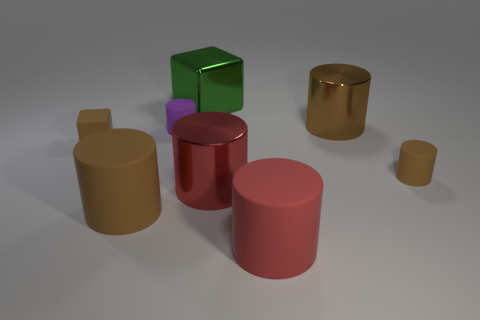Is there another tiny matte object of the same shape as the tiny purple object?
Offer a terse response. Yes. There is a large brown object that is on the right side of the red cylinder that is behind the red matte cylinder; what is it made of?
Provide a short and direct response. Metal. What is the size of the purple rubber cylinder?
Provide a short and direct response. Small. What size is the other brown cylinder that is the same material as the small brown cylinder?
Provide a short and direct response. Large. There is a cylinder left of the purple cylinder; is its size the same as the brown matte cube?
Your answer should be compact. No. What is the shape of the thing that is in front of the brown rubber thing that is in front of the metallic thing that is in front of the small block?
Your answer should be compact. Cylinder. How many objects are either large red shiny objects or matte cylinders left of the red metallic cylinder?
Your response must be concise. 3. There is a cube to the right of the big brown matte cylinder; what is its size?
Your answer should be compact. Large. There is a shiny object that is the same color as the tiny rubber cube; what shape is it?
Your answer should be very brief. Cylinder. Are the purple cylinder and the small object that is on the left side of the small purple matte object made of the same material?
Keep it short and to the point. Yes. 